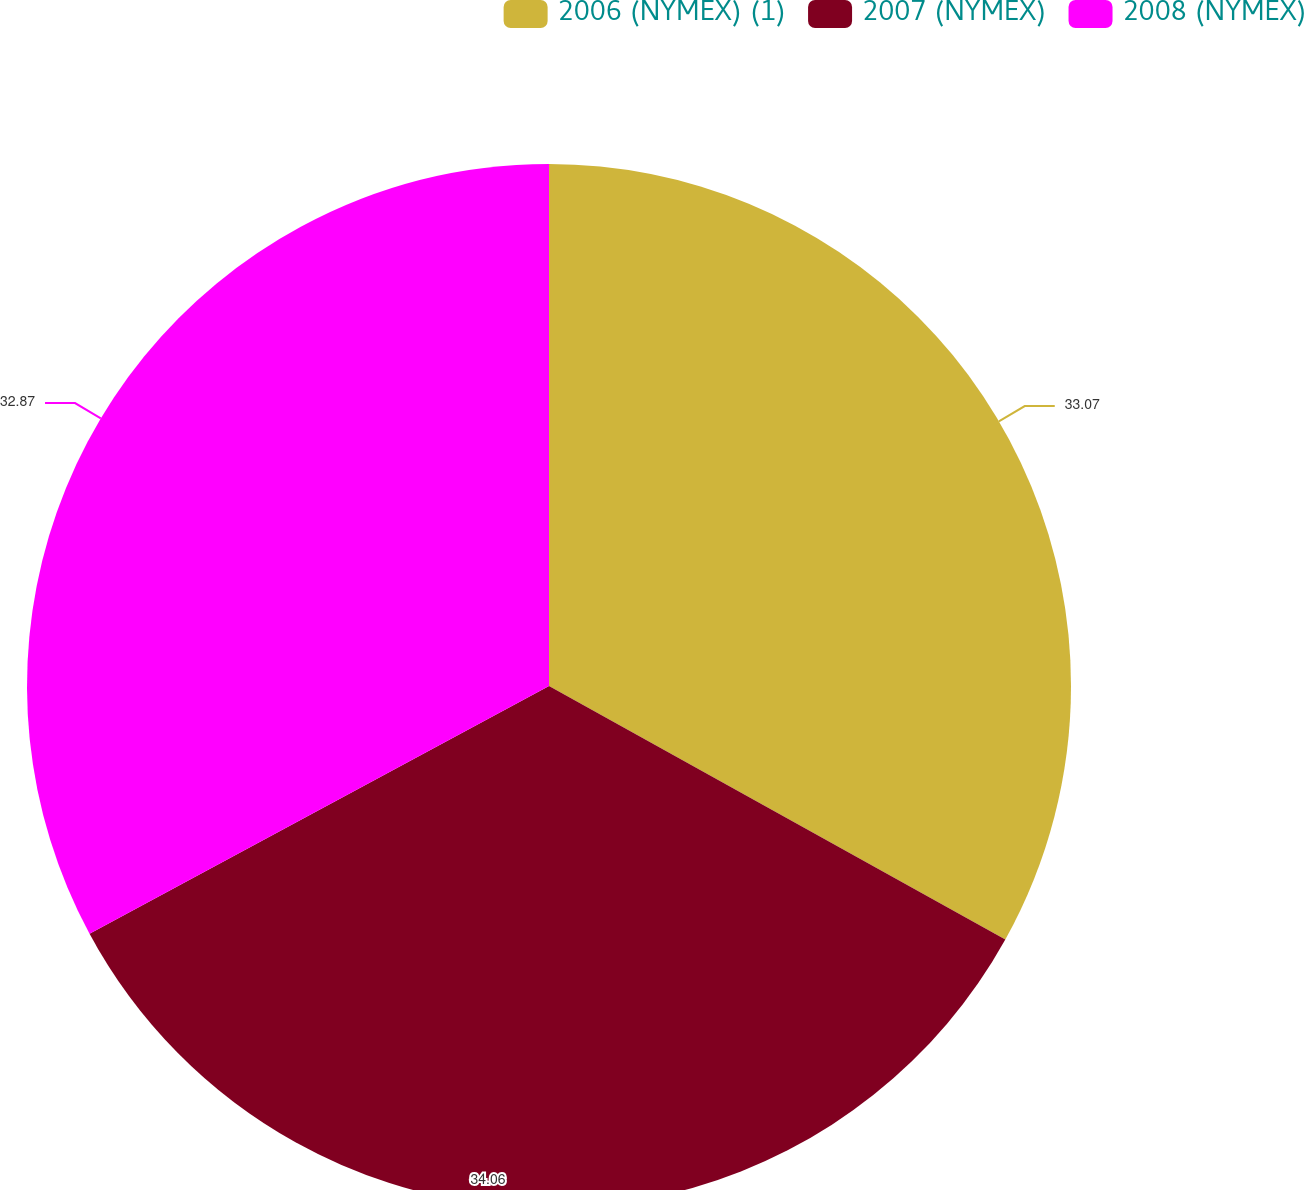<chart> <loc_0><loc_0><loc_500><loc_500><pie_chart><fcel>2006 (NYMEX) (1)<fcel>2007 (NYMEX)<fcel>2008 (NYMEX)<nl><fcel>33.07%<fcel>34.06%<fcel>32.87%<nl></chart> 